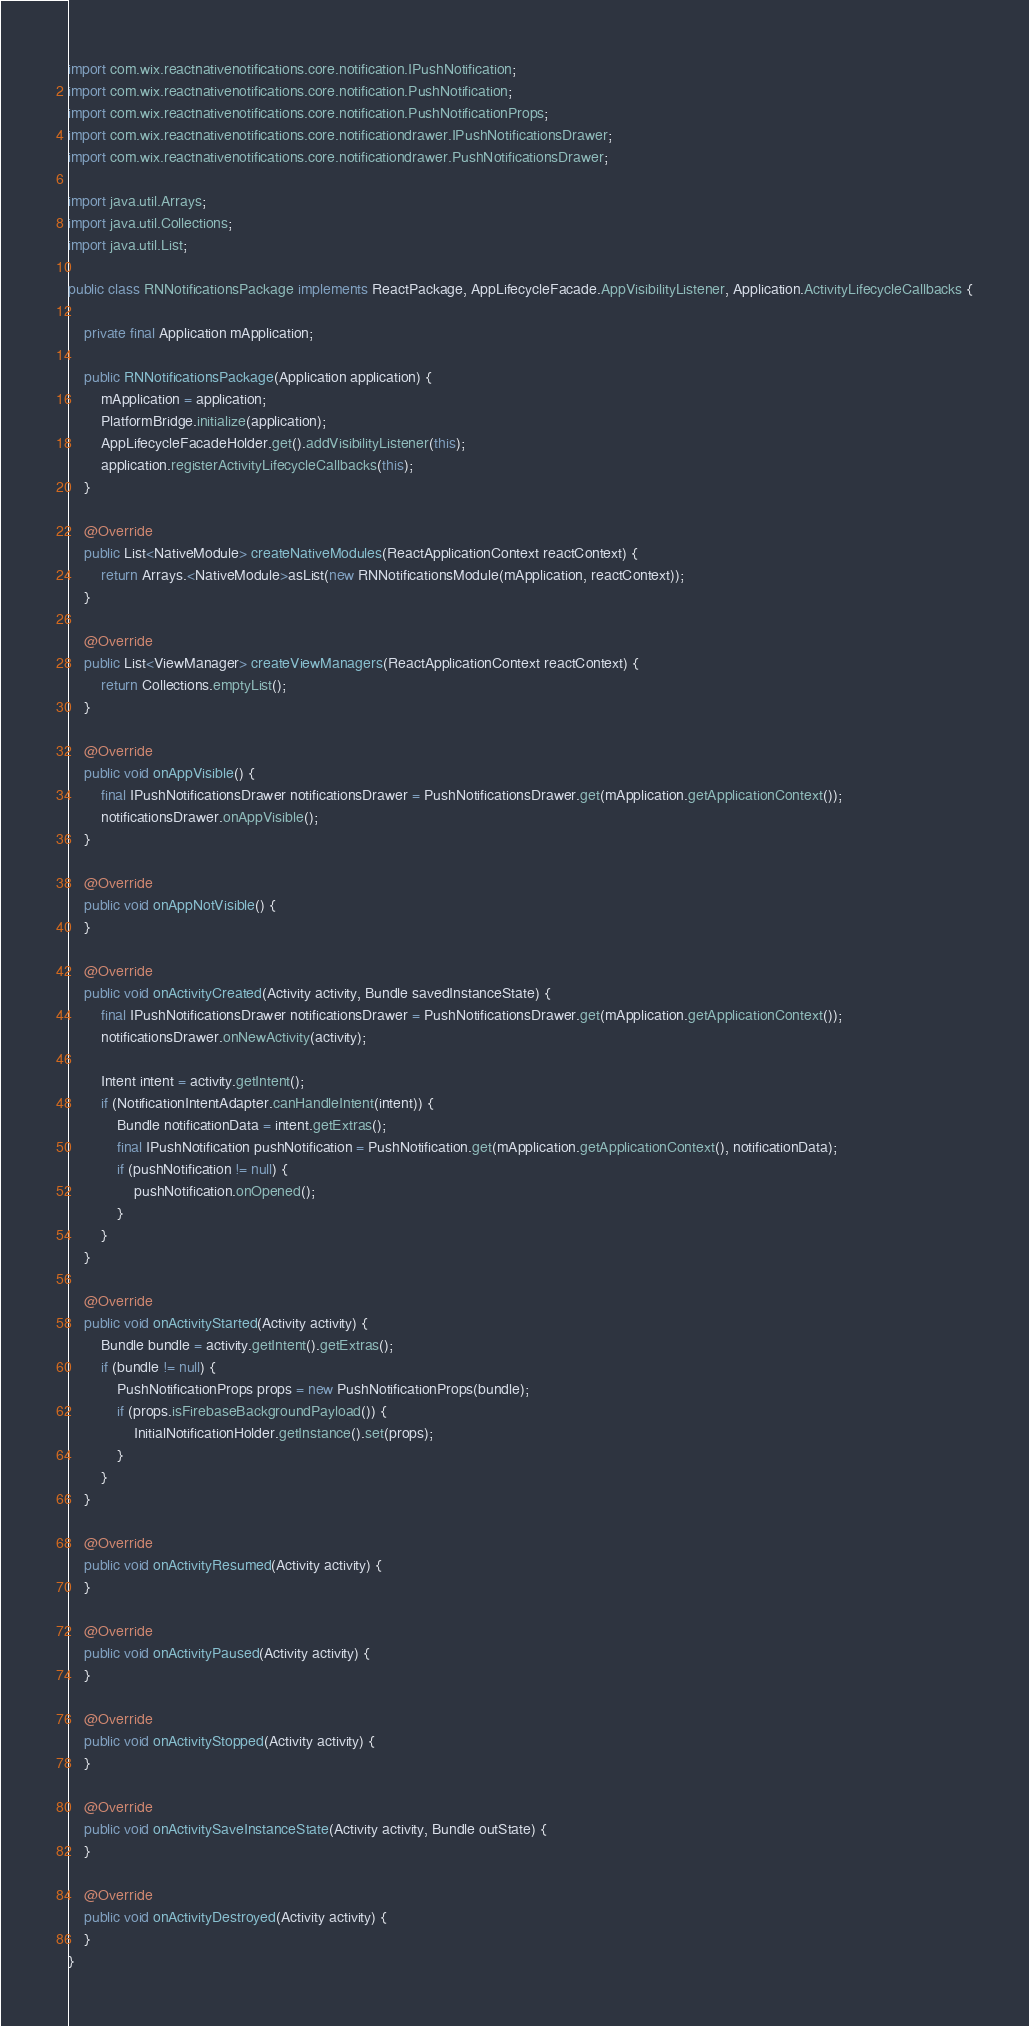Convert code to text. <code><loc_0><loc_0><loc_500><loc_500><_Java_>import com.wix.reactnativenotifications.core.notification.IPushNotification;
import com.wix.reactnativenotifications.core.notification.PushNotification;
import com.wix.reactnativenotifications.core.notification.PushNotificationProps;
import com.wix.reactnativenotifications.core.notificationdrawer.IPushNotificationsDrawer;
import com.wix.reactnativenotifications.core.notificationdrawer.PushNotificationsDrawer;

import java.util.Arrays;
import java.util.Collections;
import java.util.List;

public class RNNotificationsPackage implements ReactPackage, AppLifecycleFacade.AppVisibilityListener, Application.ActivityLifecycleCallbacks {

    private final Application mApplication;

    public RNNotificationsPackage(Application application) {
        mApplication = application;
        PlatformBridge.initialize(application);
        AppLifecycleFacadeHolder.get().addVisibilityListener(this);
        application.registerActivityLifecycleCallbacks(this);
    }

    @Override
    public List<NativeModule> createNativeModules(ReactApplicationContext reactContext) {
        return Arrays.<NativeModule>asList(new RNNotificationsModule(mApplication, reactContext));
    }

    @Override
    public List<ViewManager> createViewManagers(ReactApplicationContext reactContext) {
        return Collections.emptyList();
    }

    @Override
    public void onAppVisible() {
        final IPushNotificationsDrawer notificationsDrawer = PushNotificationsDrawer.get(mApplication.getApplicationContext());
        notificationsDrawer.onAppVisible();
    }

    @Override
    public void onAppNotVisible() {
    }

    @Override
    public void onActivityCreated(Activity activity, Bundle savedInstanceState) {
        final IPushNotificationsDrawer notificationsDrawer = PushNotificationsDrawer.get(mApplication.getApplicationContext());
        notificationsDrawer.onNewActivity(activity);

        Intent intent = activity.getIntent();
        if (NotificationIntentAdapter.canHandleIntent(intent)) {
            Bundle notificationData = intent.getExtras();
            final IPushNotification pushNotification = PushNotification.get(mApplication.getApplicationContext(), notificationData);
            if (pushNotification != null) {
                pushNotification.onOpened();
            }
        }
    }

    @Override
    public void onActivityStarted(Activity activity) {
        Bundle bundle = activity.getIntent().getExtras();
        if (bundle != null) {
            PushNotificationProps props = new PushNotificationProps(bundle);
            if (props.isFirebaseBackgroundPayload()) {
                InitialNotificationHolder.getInstance().set(props);
            }
        }
    }

    @Override
    public void onActivityResumed(Activity activity) {
    }

    @Override
    public void onActivityPaused(Activity activity) {
    }

    @Override
    public void onActivityStopped(Activity activity) {
    }

    @Override
    public void onActivitySaveInstanceState(Activity activity, Bundle outState) {
    }

    @Override
    public void onActivityDestroyed(Activity activity) {
    }
}
</code> 